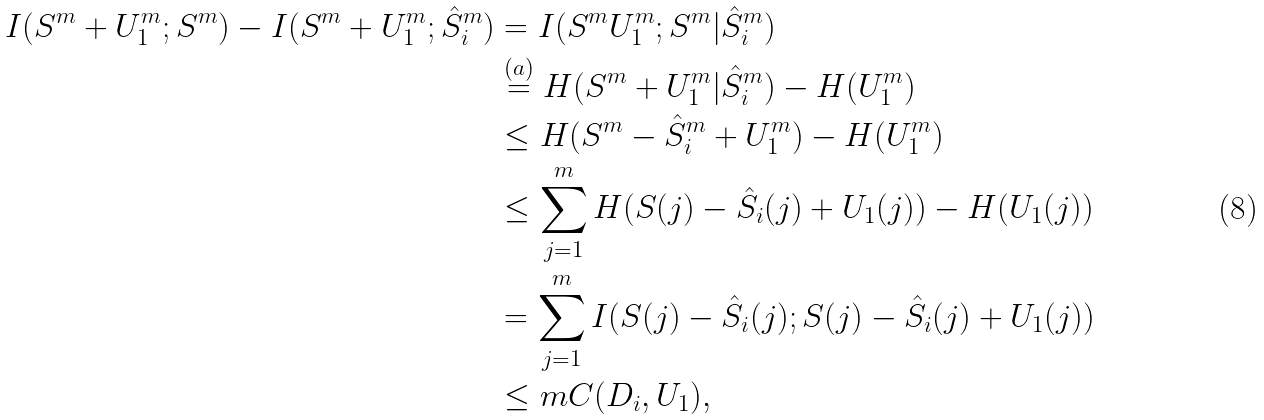Convert formula to latex. <formula><loc_0><loc_0><loc_500><loc_500>I ( S ^ { m } + U ^ { m } _ { 1 } ; S ^ { m } ) - I ( S ^ { m } + U ^ { m } _ { 1 } ; \hat { S } ^ { m } _ { i } ) & = I ( S ^ { m } U ^ { m } _ { 1 } ; S ^ { m } | \hat { S } ^ { m } _ { i } ) \\ & \stackrel { ( a ) } { = } H ( S ^ { m } + U ^ { m } _ { 1 } | \hat { S } ^ { m } _ { i } ) - H ( U ^ { m } _ { 1 } ) \\ & \leq H ( S ^ { m } - \hat { S } ^ { m } _ { i } + U ^ { m } _ { 1 } ) - H ( U ^ { m } _ { 1 } ) \\ & \leq \sum _ { j = 1 } ^ { m } H ( S ( j ) - \hat { S } _ { i } ( j ) + U _ { 1 } ( j ) ) - H ( U _ { 1 } ( j ) ) \\ & = \sum _ { j = 1 } ^ { m } I ( S ( j ) - \hat { S } _ { i } ( j ) ; S ( j ) - \hat { S } _ { i } ( j ) + U _ { 1 } ( j ) ) \\ & \leq m C ( D _ { i } , U _ { 1 } ) ,</formula> 